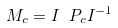<formula> <loc_0><loc_0><loc_500><loc_500>M _ { c } = I \ P _ { c } I ^ { - 1 }</formula> 